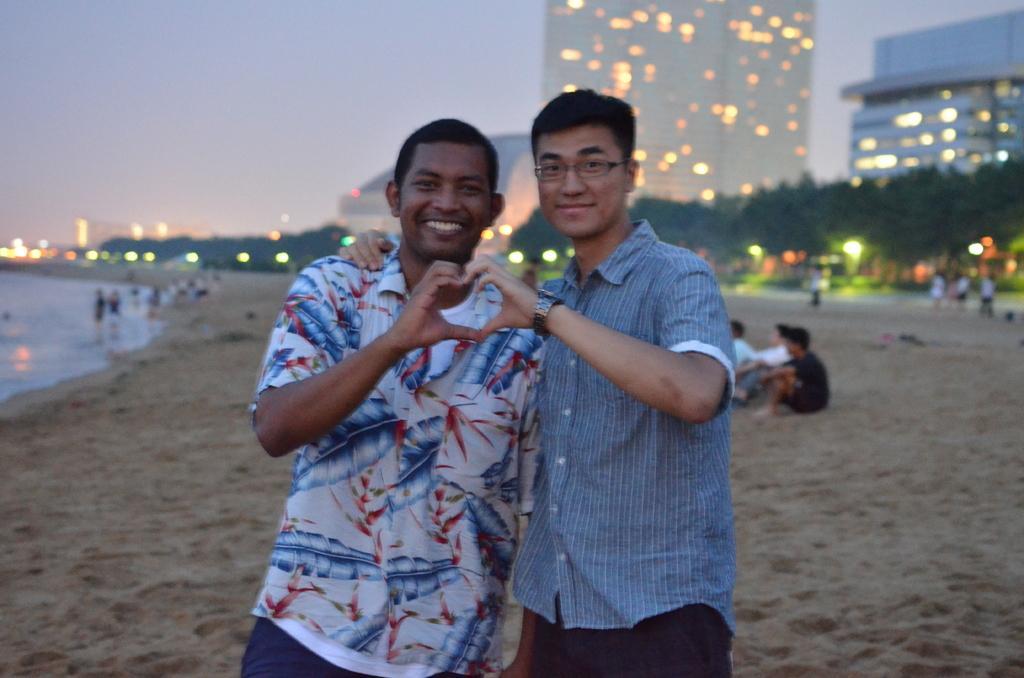Describe this image in one or two sentences. In this image in the foreground there are two persons visible, in the background there are buildings, the sky tree, people, lights, on the left side there is a sea shore , in front of sea shore there are few people visible. 